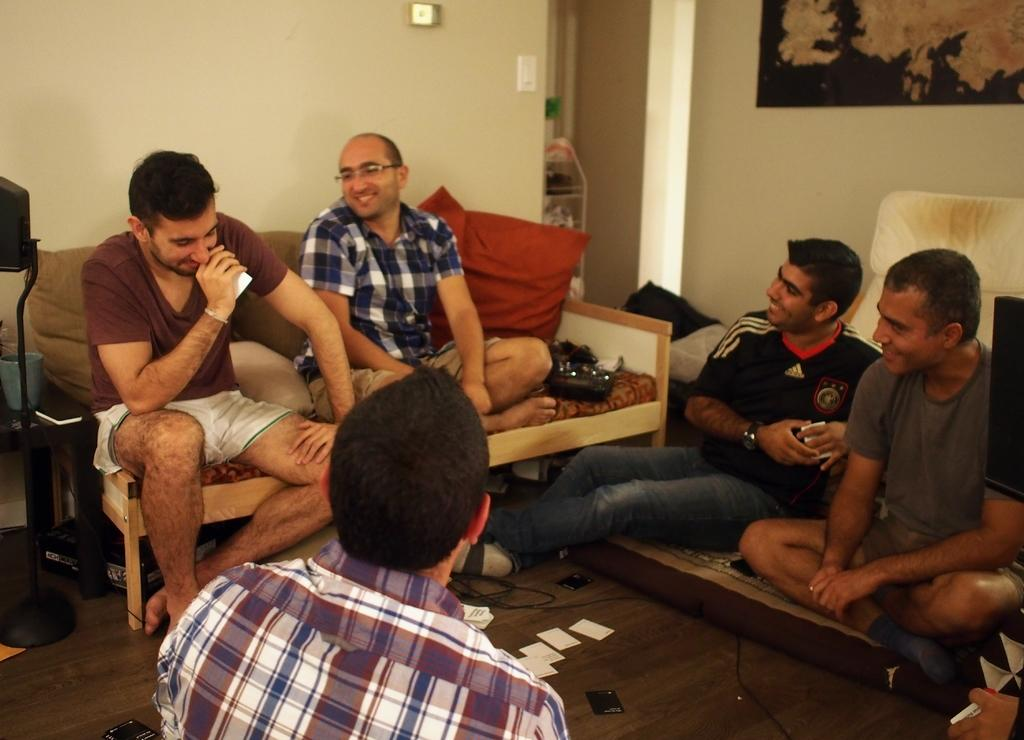What are the people in the image doing? The people in the image are sitting. What can be seen on the floor in the image? Cards are present on the floor in the image. What is visible in the background of the image? There are objects in the background of the image, including a portrait. What type of wood is used to make the arm of the chair in the image? There is no information about the type of wood used in the chair, nor is there any mention of an arm in the chair. 